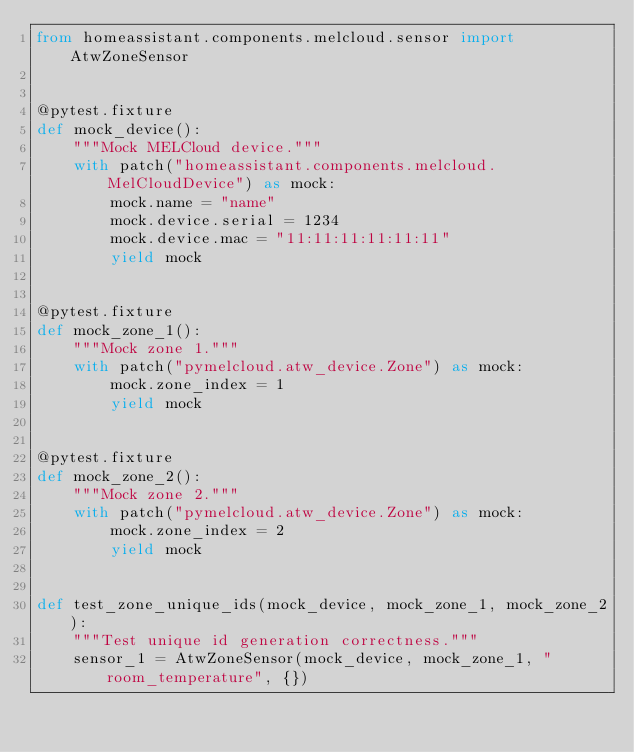Convert code to text. <code><loc_0><loc_0><loc_500><loc_500><_Python_>from homeassistant.components.melcloud.sensor import AtwZoneSensor


@pytest.fixture
def mock_device():
    """Mock MELCloud device."""
    with patch("homeassistant.components.melcloud.MelCloudDevice") as mock:
        mock.name = "name"
        mock.device.serial = 1234
        mock.device.mac = "11:11:11:11:11:11"
        yield mock


@pytest.fixture
def mock_zone_1():
    """Mock zone 1."""
    with patch("pymelcloud.atw_device.Zone") as mock:
        mock.zone_index = 1
        yield mock


@pytest.fixture
def mock_zone_2():
    """Mock zone 2."""
    with patch("pymelcloud.atw_device.Zone") as mock:
        mock.zone_index = 2
        yield mock


def test_zone_unique_ids(mock_device, mock_zone_1, mock_zone_2):
    """Test unique id generation correctness."""
    sensor_1 = AtwZoneSensor(mock_device, mock_zone_1, "room_temperature", {})</code> 